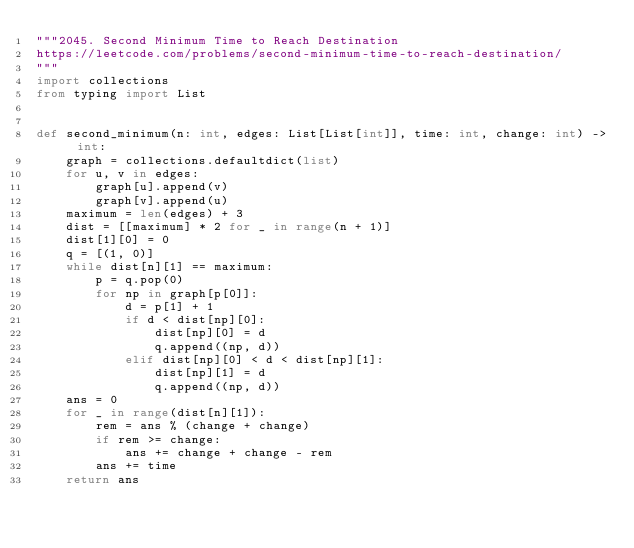Convert code to text. <code><loc_0><loc_0><loc_500><loc_500><_Python_>"""2045. Second Minimum Time to Reach Destination
https://leetcode.com/problems/second-minimum-time-to-reach-destination/
"""
import collections
from typing import List


def second_minimum(n: int, edges: List[List[int]], time: int, change: int) -> int:
    graph = collections.defaultdict(list)
    for u, v in edges:
        graph[u].append(v)
        graph[v].append(u)
    maximum = len(edges) + 3
    dist = [[maximum] * 2 for _ in range(n + 1)]
    dist[1][0] = 0
    q = [(1, 0)]
    while dist[n][1] == maximum:
        p = q.pop(0)
        for np in graph[p[0]]:
            d = p[1] + 1
            if d < dist[np][0]:
                dist[np][0] = d
                q.append((np, d))
            elif dist[np][0] < d < dist[np][1]:
                dist[np][1] = d
                q.append((np, d))
    ans = 0
    for _ in range(dist[n][1]):
        rem = ans % (change + change)
        if rem >= change:
            ans += change + change - rem
        ans += time
    return ans
</code> 